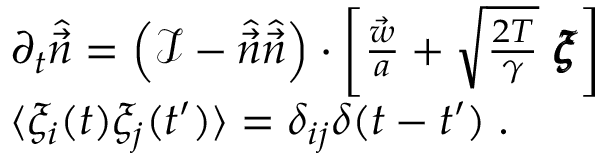<formula> <loc_0><loc_0><loc_500><loc_500>\begin{array} { r l } & { \partial _ { t } \hat { \vec { n } } = \left ( \mathcal { I } - \hat { \vec { n } } \hat { \vec { n } } \right ) \cdot \left [ \frac { \vec { w } } { a } + \sqrt { \frac { 2 T } { \gamma } } \ \pm b { \xi } \right ] } \\ & { \langle \xi _ { i } ( t ) \xi _ { j } ( t ^ { \prime } ) \rangle = \delta _ { i j } \delta ( t - t ^ { \prime } ) \, . } \end{array}</formula> 